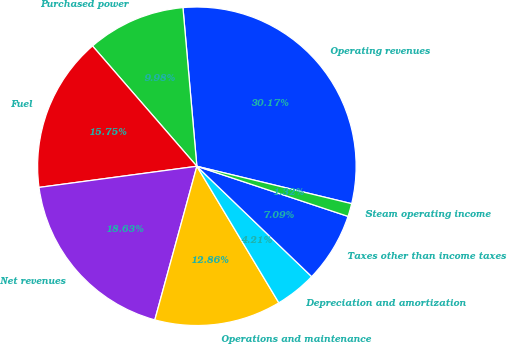Convert chart to OTSL. <chart><loc_0><loc_0><loc_500><loc_500><pie_chart><fcel>Operating revenues<fcel>Purchased power<fcel>Fuel<fcel>Net revenues<fcel>Operations and maintenance<fcel>Depreciation and amortization<fcel>Taxes other than income taxes<fcel>Steam operating income<nl><fcel>30.17%<fcel>9.98%<fcel>15.75%<fcel>18.63%<fcel>12.86%<fcel>4.21%<fcel>7.09%<fcel>1.32%<nl></chart> 